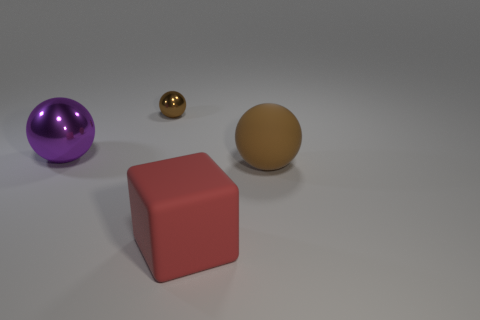Add 4 large cubes. How many objects exist? 8 Subtract all spheres. How many objects are left? 1 Subtract 0 blue cylinders. How many objects are left? 4 Subtract all tiny matte things. Subtract all brown balls. How many objects are left? 2 Add 3 purple metal balls. How many purple metal balls are left? 4 Add 3 red spheres. How many red spheres exist? 3 